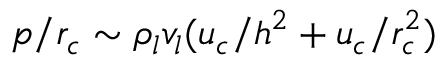Convert formula to latex. <formula><loc_0><loc_0><loc_500><loc_500>p / { r _ { c } } \sim { \rho _ { l } } { v _ { l } } ( { u _ { c } } / { h ^ { 2 } } + { u _ { c } } / r _ { c } ^ { 2 } )</formula> 